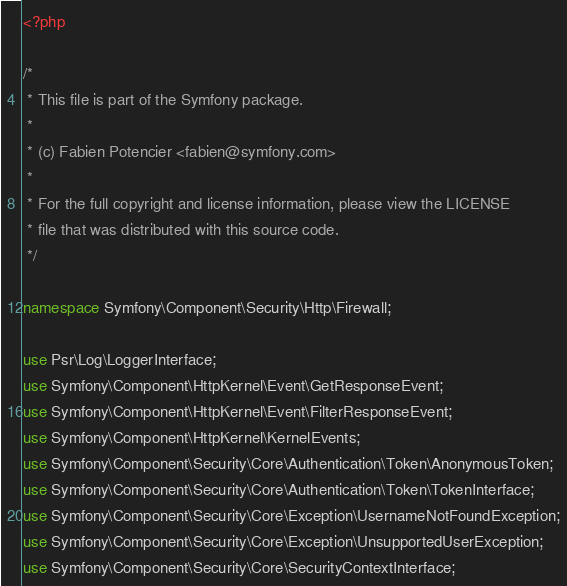<code> <loc_0><loc_0><loc_500><loc_500><_PHP_><?php

/*
 * This file is part of the Symfony package.
 *
 * (c) Fabien Potencier <fabien@symfony.com>
 *
 * For the full copyright and license information, please view the LICENSE
 * file that was distributed with this source code.
 */

namespace Symfony\Component\Security\Http\Firewall;

use Psr\Log\LoggerInterface;
use Symfony\Component\HttpKernel\Event\GetResponseEvent;
use Symfony\Component\HttpKernel\Event\FilterResponseEvent;
use Symfony\Component\HttpKernel\KernelEvents;
use Symfony\Component\Security\Core\Authentication\Token\AnonymousToken;
use Symfony\Component\Security\Core\Authentication\Token\TokenInterface;
use Symfony\Component\Security\Core\Exception\UsernameNotFoundException;
use Symfony\Component\Security\Core\Exception\UnsupportedUserException;
use Symfony\Component\Security\Core\SecurityContextInterface;</code> 